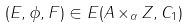Convert formula to latex. <formula><loc_0><loc_0><loc_500><loc_500>( E , \phi , F ) \in { E } ( A \times _ { \alpha } { Z } , { C } _ { 1 } )</formula> 